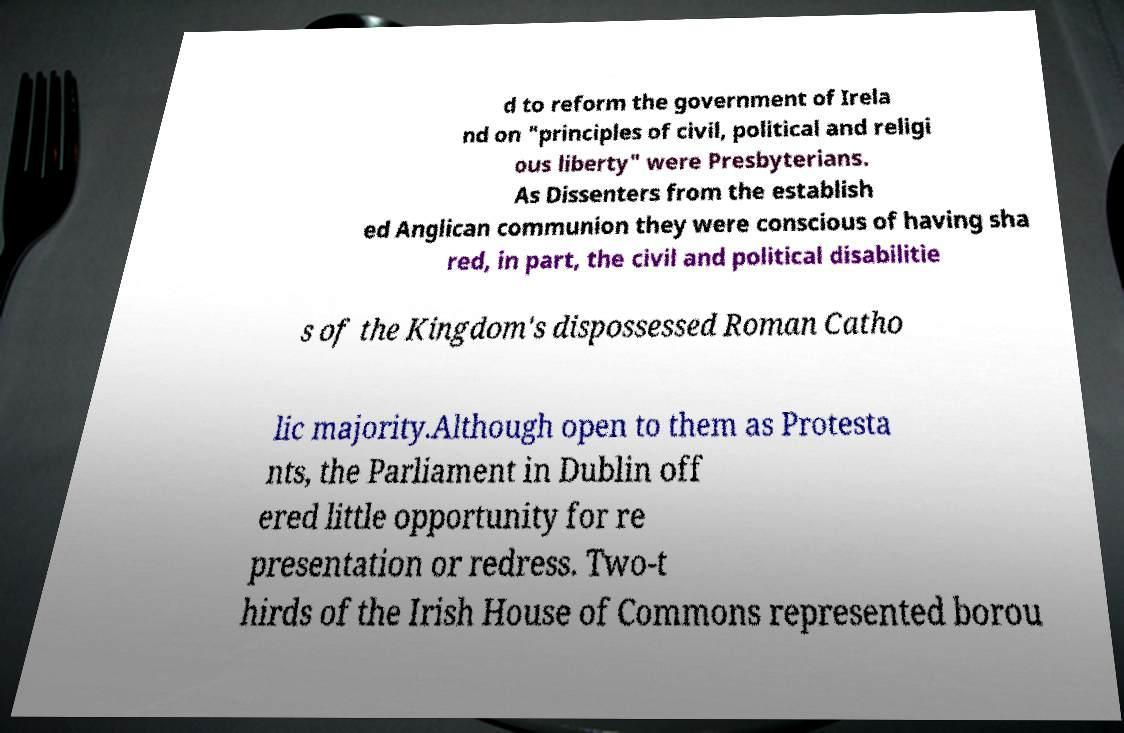Can you accurately transcribe the text from the provided image for me? d to reform the government of Irela nd on "principles of civil, political and religi ous liberty" were Presbyterians. As Dissenters from the establish ed Anglican communion they were conscious of having sha red, in part, the civil and political disabilitie s of the Kingdom's dispossessed Roman Catho lic majority.Although open to them as Protesta nts, the Parliament in Dublin off ered little opportunity for re presentation or redress. Two-t hirds of the Irish House of Commons represented borou 